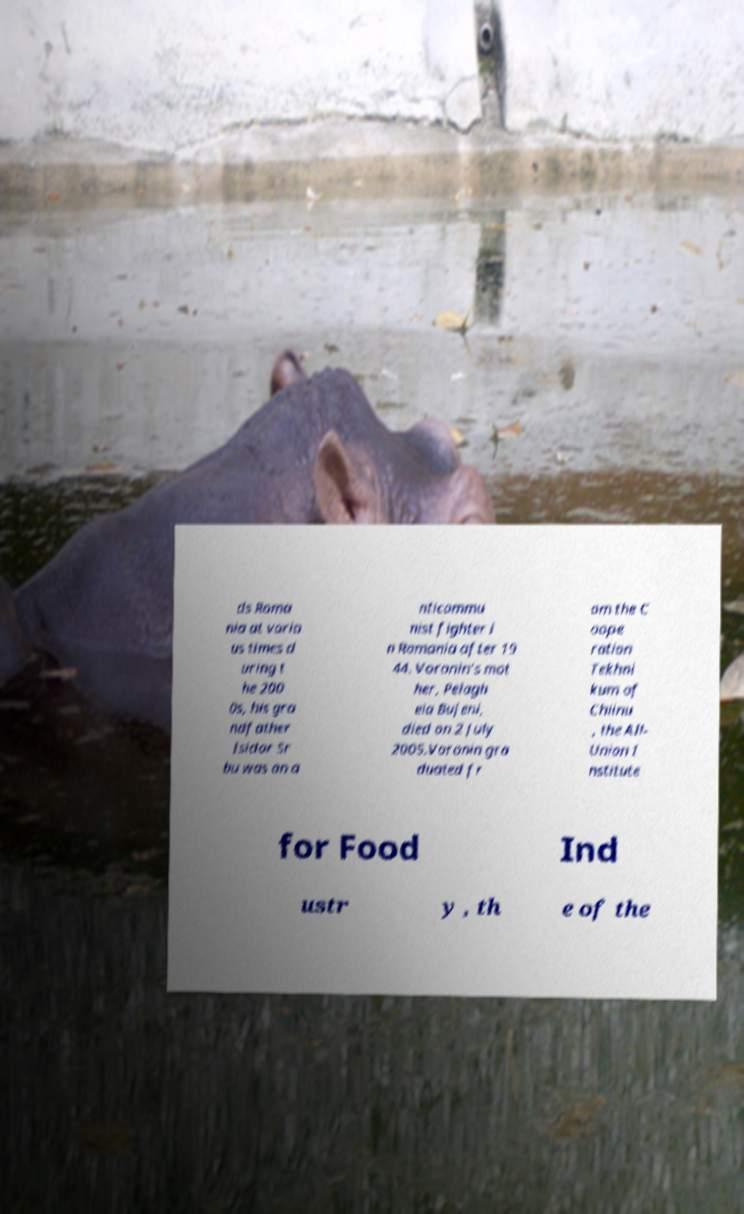What messages or text are displayed in this image? I need them in a readable, typed format. ds Roma nia at vario us times d uring t he 200 0s, his gra ndfather Isidor Sr bu was an a nticommu nist fighter i n Romania after 19 44. Voronin's mot her, Pelagh eia Bujeni, died on 2 July 2005.Voronin gra duated fr om the C oope ration Tekhni kum of Chiinu , the All- Union I nstitute for Food Ind ustr y , th e of the 